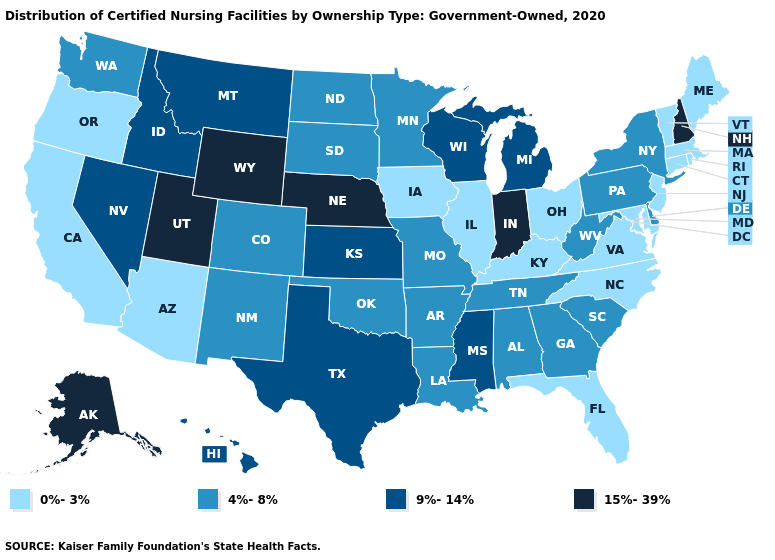Name the states that have a value in the range 4%-8%?
Keep it brief. Alabama, Arkansas, Colorado, Delaware, Georgia, Louisiana, Minnesota, Missouri, New Mexico, New York, North Dakota, Oklahoma, Pennsylvania, South Carolina, South Dakota, Tennessee, Washington, West Virginia. Does Arizona have the highest value in the USA?
Be succinct. No. Is the legend a continuous bar?
Short answer required. No. Name the states that have a value in the range 0%-3%?
Quick response, please. Arizona, California, Connecticut, Florida, Illinois, Iowa, Kentucky, Maine, Maryland, Massachusetts, New Jersey, North Carolina, Ohio, Oregon, Rhode Island, Vermont, Virginia. Does the first symbol in the legend represent the smallest category?
Answer briefly. Yes. What is the value of Rhode Island?
Give a very brief answer. 0%-3%. Name the states that have a value in the range 0%-3%?
Quick response, please. Arizona, California, Connecticut, Florida, Illinois, Iowa, Kentucky, Maine, Maryland, Massachusetts, New Jersey, North Carolina, Ohio, Oregon, Rhode Island, Vermont, Virginia. What is the lowest value in the MidWest?
Concise answer only. 0%-3%. What is the value of Rhode Island?
Give a very brief answer. 0%-3%. Which states hav the highest value in the Northeast?
Concise answer only. New Hampshire. What is the value of Utah?
Concise answer only. 15%-39%. Is the legend a continuous bar?
Answer briefly. No. What is the value of New Jersey?
Keep it brief. 0%-3%. Among the states that border Tennessee , which have the lowest value?
Concise answer only. Kentucky, North Carolina, Virginia. What is the value of North Dakota?
Keep it brief. 4%-8%. 